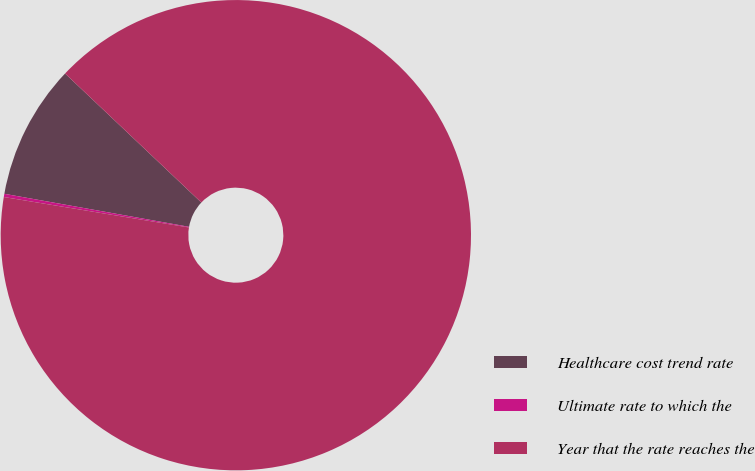<chart> <loc_0><loc_0><loc_500><loc_500><pie_chart><fcel>Healthcare cost trend rate<fcel>Ultimate rate to which the<fcel>Year that the rate reaches the<nl><fcel>9.25%<fcel>0.22%<fcel>90.52%<nl></chart> 